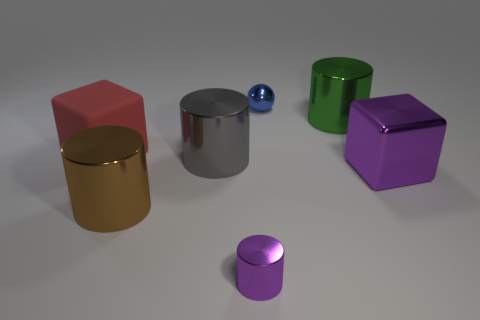Subtract all big brown metal cylinders. How many cylinders are left? 3 Subtract all red cylinders. Subtract all purple blocks. How many cylinders are left? 4 Add 2 big cylinders. How many objects exist? 9 Subtract all spheres. How many objects are left? 6 Add 3 large purple cubes. How many large purple cubes exist? 4 Subtract 0 yellow cylinders. How many objects are left? 7 Subtract all cylinders. Subtract all purple metal objects. How many objects are left? 1 Add 6 brown cylinders. How many brown cylinders are left? 7 